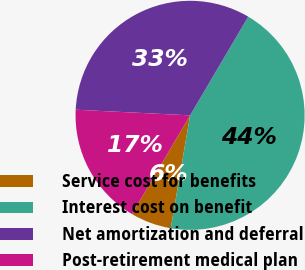Convert chart to OTSL. <chart><loc_0><loc_0><loc_500><loc_500><pie_chart><fcel>Service cost for benefits<fcel>Interest cost on benefit<fcel>Net amortization and deferral<fcel>Post-retirement medical plan<nl><fcel>5.77%<fcel>44.23%<fcel>32.69%<fcel>17.31%<nl></chart> 